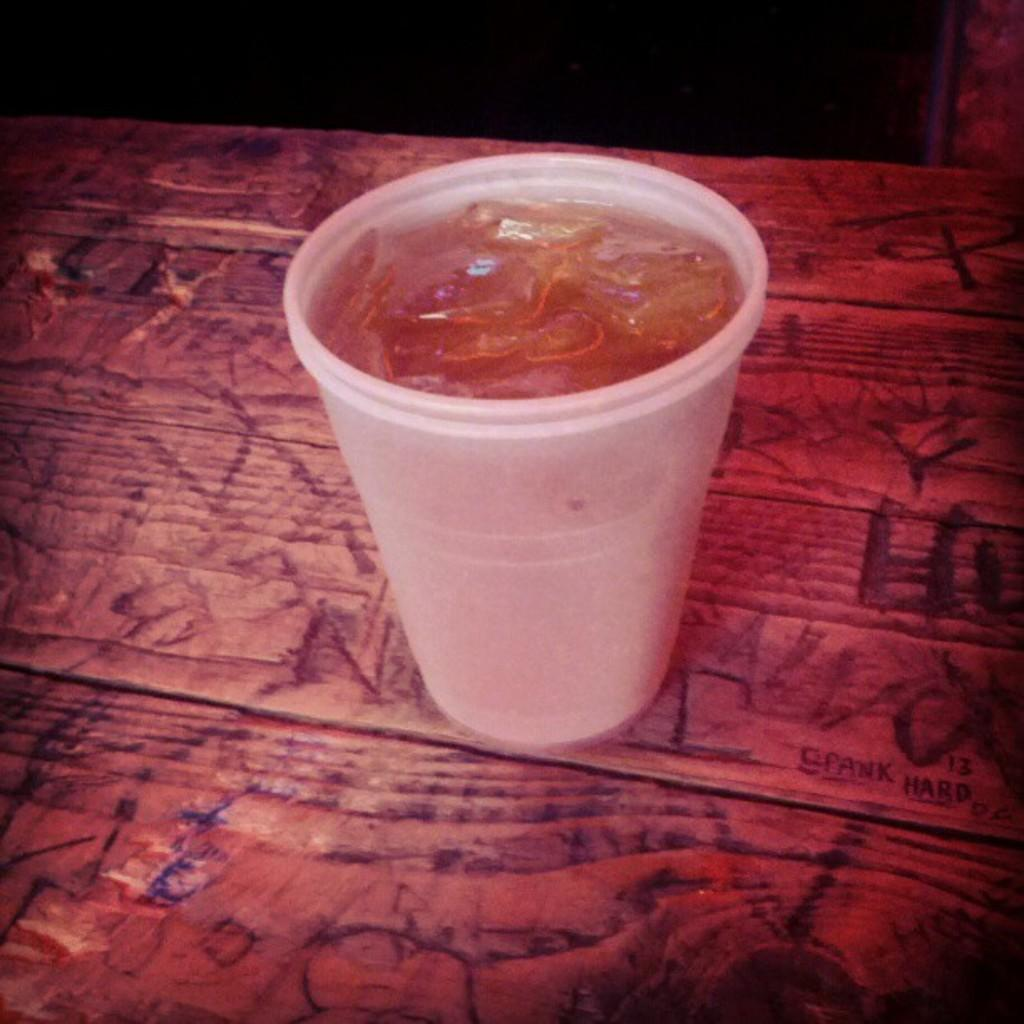What is inside the glass that is visible in the image? There is a drink and ice in the glass in the image. Where is the glass placed in the image? The glass is placed on a wooden table in the image. What can be observed about the background of the image? The background of the image is dark in color. What type of eggnog is being served in the room in the image? There is no room or eggnog present in the image; it only features a glass filled with a drink and ice on a wooden table. 